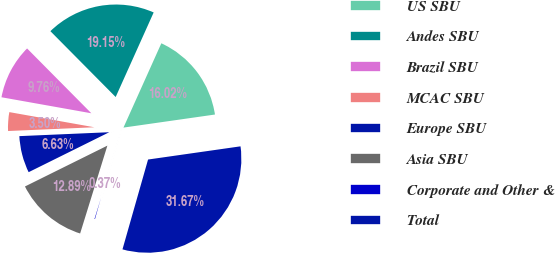Convert chart to OTSL. <chart><loc_0><loc_0><loc_500><loc_500><pie_chart><fcel>US SBU<fcel>Andes SBU<fcel>Brazil SBU<fcel>MCAC SBU<fcel>Europe SBU<fcel>Asia SBU<fcel>Corporate and Other &<fcel>Total<nl><fcel>16.02%<fcel>19.15%<fcel>9.76%<fcel>3.5%<fcel>6.63%<fcel>12.89%<fcel>0.37%<fcel>31.67%<nl></chart> 